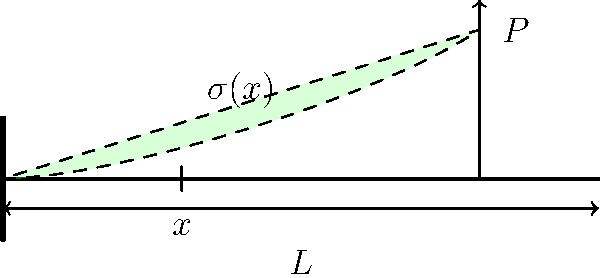A cantilever beam of length $L$ is subjected to a point load $P$ at its free end. Derive an expression for the bending stress $\sigma(x)$ at any point $x$ along the beam's length. Assume the beam has a rectangular cross-section with width $b$ and height $h$. To derive the expression for bending stress, we'll follow these steps:

1) The bending moment $M(x)$ at any point $x$ along the beam is:
   $$M(x) = P(L-x)$$

2) The moment of inertia $I$ for a rectangular cross-section is:
   $$I = \frac{bh^3}{12}$$

3) The bending stress $\sigma(x)$ at any point in the beam is given by the flexure formula:
   $$\sigma(x) = \frac{My}{I}$$
   where $y$ is the distance from the neutral axis (half the height for a rectangular beam).

4) Substituting the expressions for $M(x)$ and $I$, and using $y = h/2$:
   $$\sigma(x) = \frac{P(L-x) \cdot (h/2)}{\frac{bh^3}{12}}$$

5) Simplifying:
   $$\sigma(x) = \frac{6P(L-x)}{bh^2}$$

This equation shows that the bending stress varies linearly along the length of the beam, with maximum stress at the fixed end ($x=0$) and zero stress at the free end ($x=L$).
Answer: $$\sigma(x) = \frac{6P(L-x)}{bh^2}$$ 